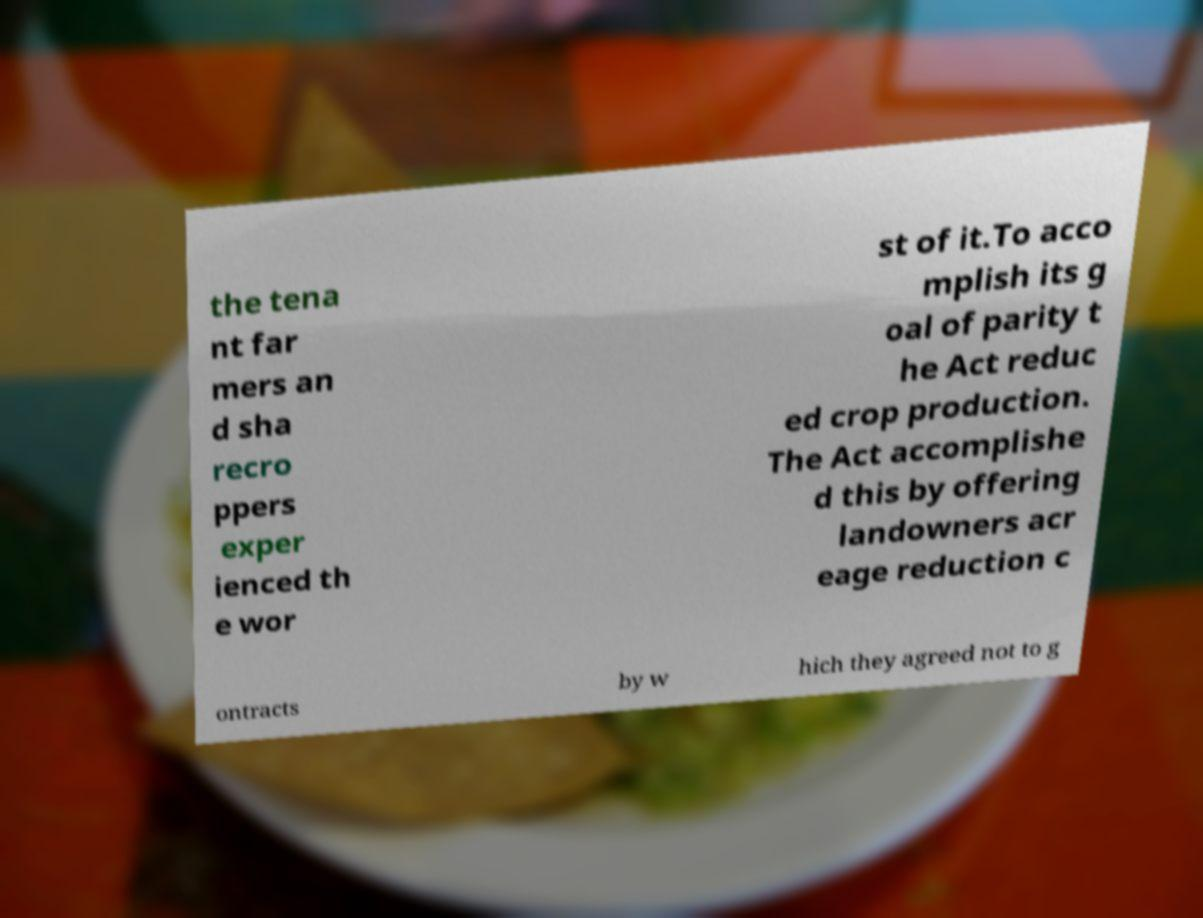Can you read and provide the text displayed in the image?This photo seems to have some interesting text. Can you extract and type it out for me? the tena nt far mers an d sha recro ppers exper ienced th e wor st of it.To acco mplish its g oal of parity t he Act reduc ed crop production. The Act accomplishe d this by offering landowners acr eage reduction c ontracts by w hich they agreed not to g 